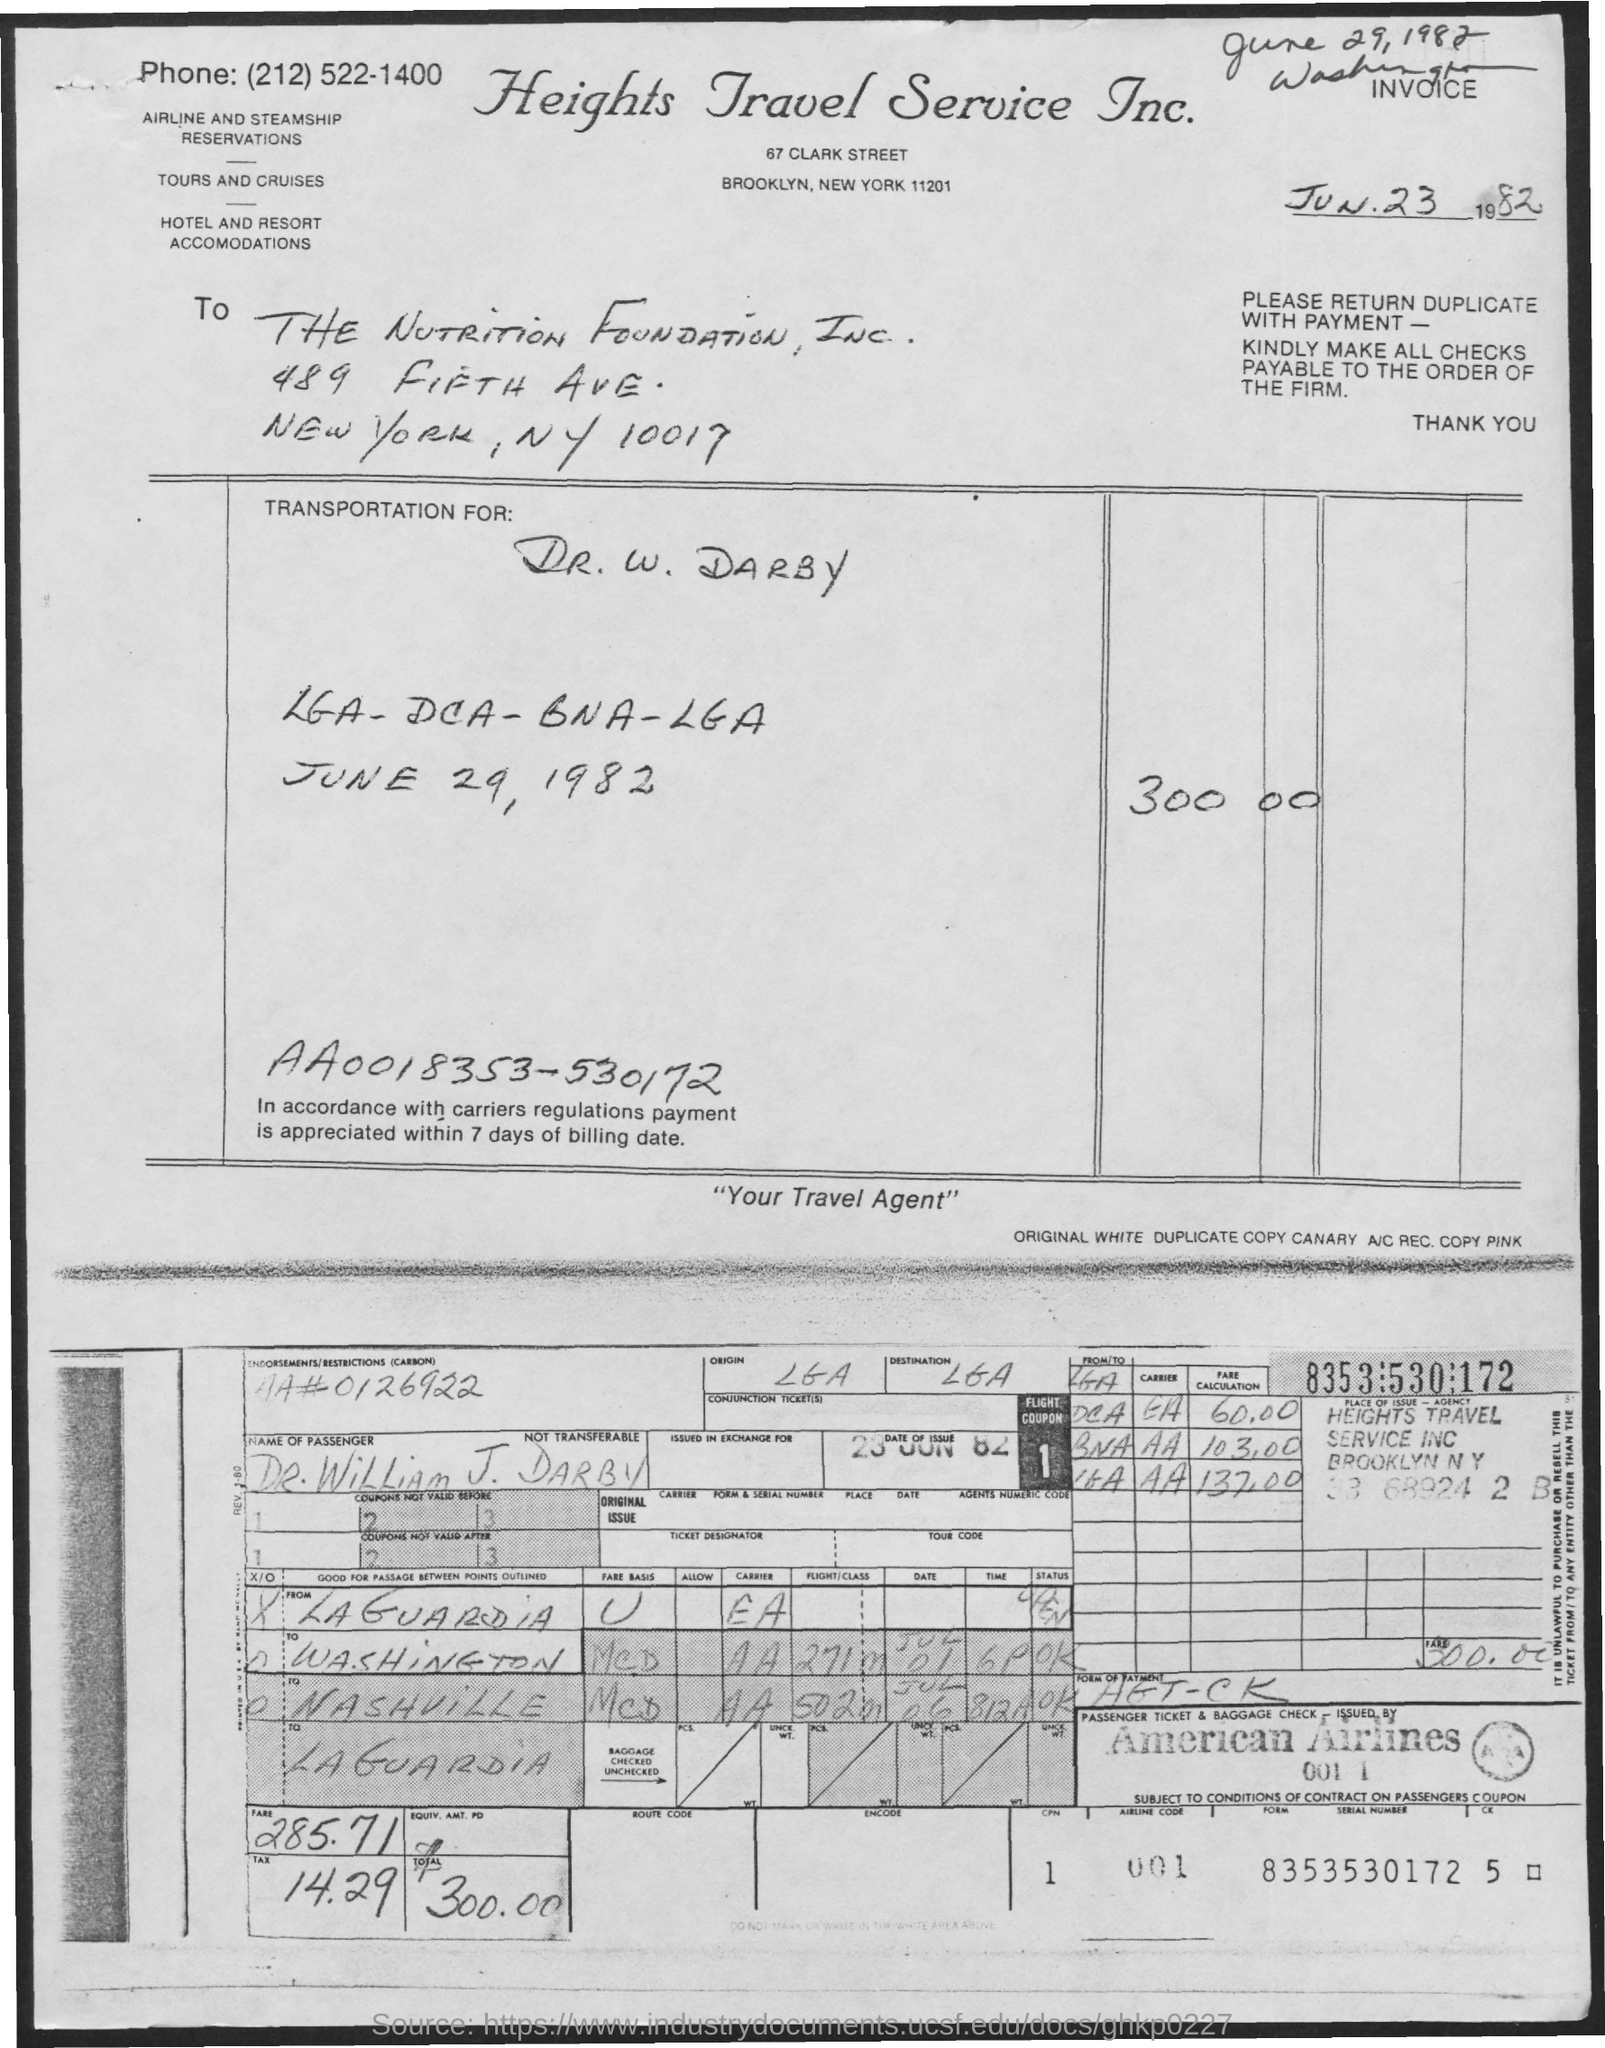Draw attention to some important aspects in this diagram. Heights Travel Service Inc. is located in zip code 11201. Heights Travel Service Inc. declares "Your Travel Agent" to be its tagline, conveying its expertise and dedication in providing travel services to its customers. The date of issue of the invoice is June 23, 1982. Heights Travel Service Inc. can be contacted at (212)522-1400. The postal code for the Nutrition Foundation is 10017. 